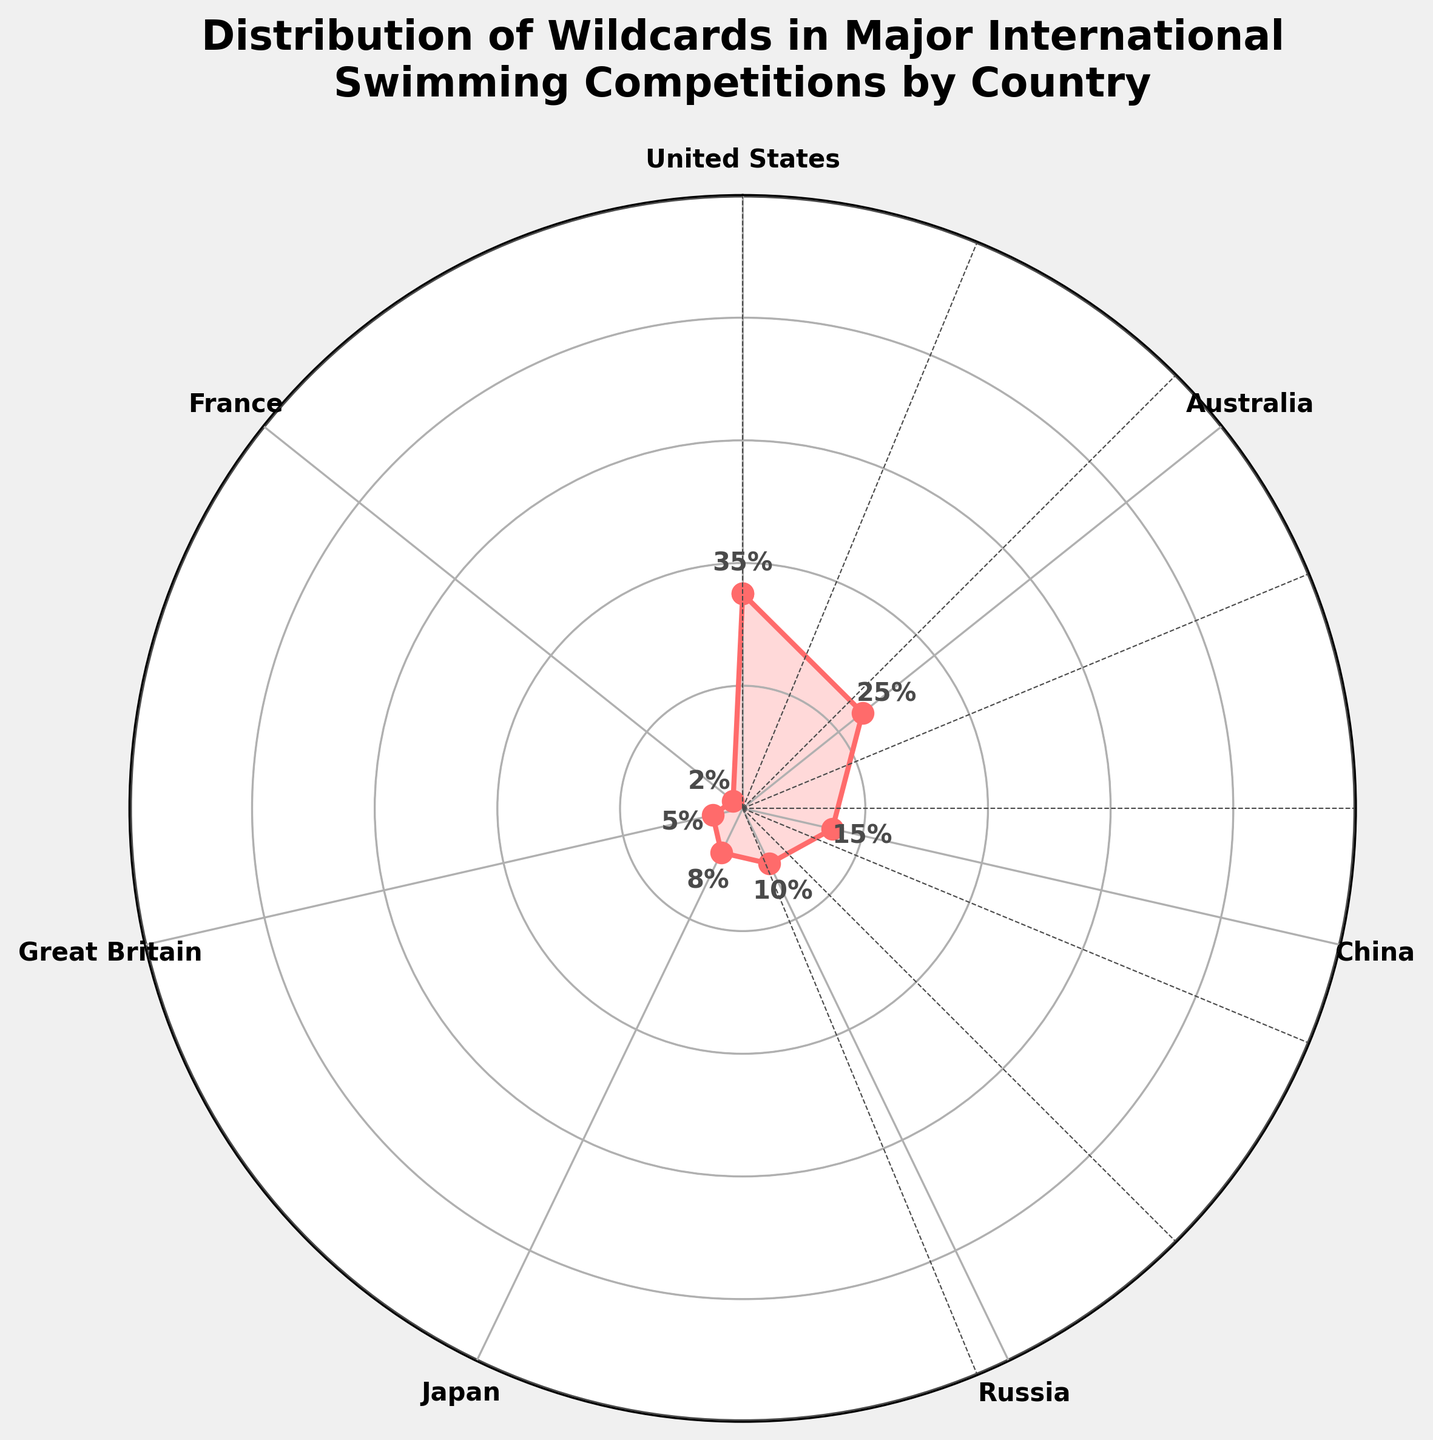What country has the highest percentage of wildcards? The rightmost data point on the plot shows that the United States has the highest wildcard percentage.
Answer: United States What is the wildcard percentage for China? From the plot, the angle for China shows a percentage label of 15%.
Answer: 15% How many countries have a wildcard percentage below 10%? Great Britain and France have percentages below 10%. There are 2 such countries.
Answer: 2 What is the difference in wildcard percentage between the United States and Japan? The United States has 35% and Japan has 8%. The difference is 35% - 8%.
Answer: 27% Which country has the lowest percentage of wildcards? From the plot, France has the lowest percentage of wildcards, which is 2%.
Answer: France What's the average wildcard percentage for all countries listed? Adding all wildcard percentages (35 + 25 + 15 + 10 + 8 + 5 + 2) gives 100. Dividing this by 7 (the number of countries) gives the average.
Answer: 14.29% How many countries have a wildcard percentage above 20%? The United States and Australia have percentages above 20%. There are 2 such countries.
Answer: 2 Which country has a wildcard percentage closer to the median percentage? The median percentage of the given data is 10% (the middle value when sorted). China with 15% and Russia with 10% are close, but Japan with 8% is closer to the median.
Answer: Russia If you sum the wildcard percentages of Russia, Japan, and Great Britain, what is the total? Adding the percentages (10 + 8 + 5) results in 23%.
Answer: 23% In terms of wildcard percentage, which country ranks third? The third highest percentage after the United States and Australia is China with 15%.
Answer: China 